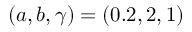<formula> <loc_0><loc_0><loc_500><loc_500>( a , b , \gamma ) = ( 0 . 2 , 2 , 1 )</formula> 